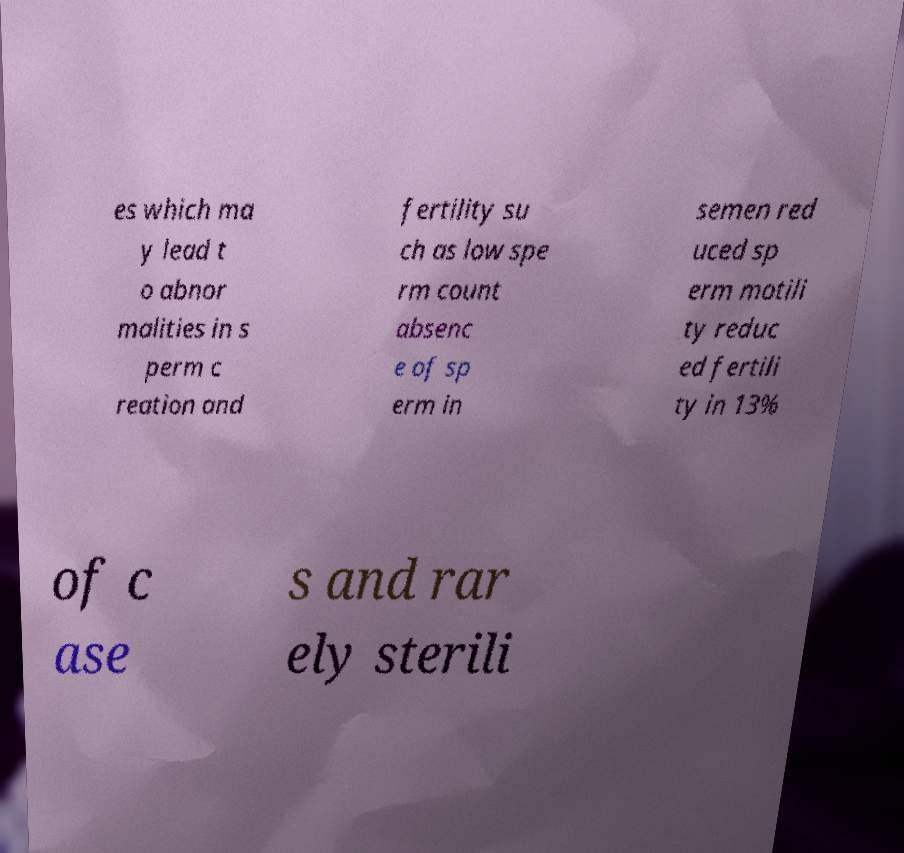I need the written content from this picture converted into text. Can you do that? es which ma y lead t o abnor malities in s perm c reation and fertility su ch as low spe rm count absenc e of sp erm in semen red uced sp erm motili ty reduc ed fertili ty in 13% of c ase s and rar ely sterili 